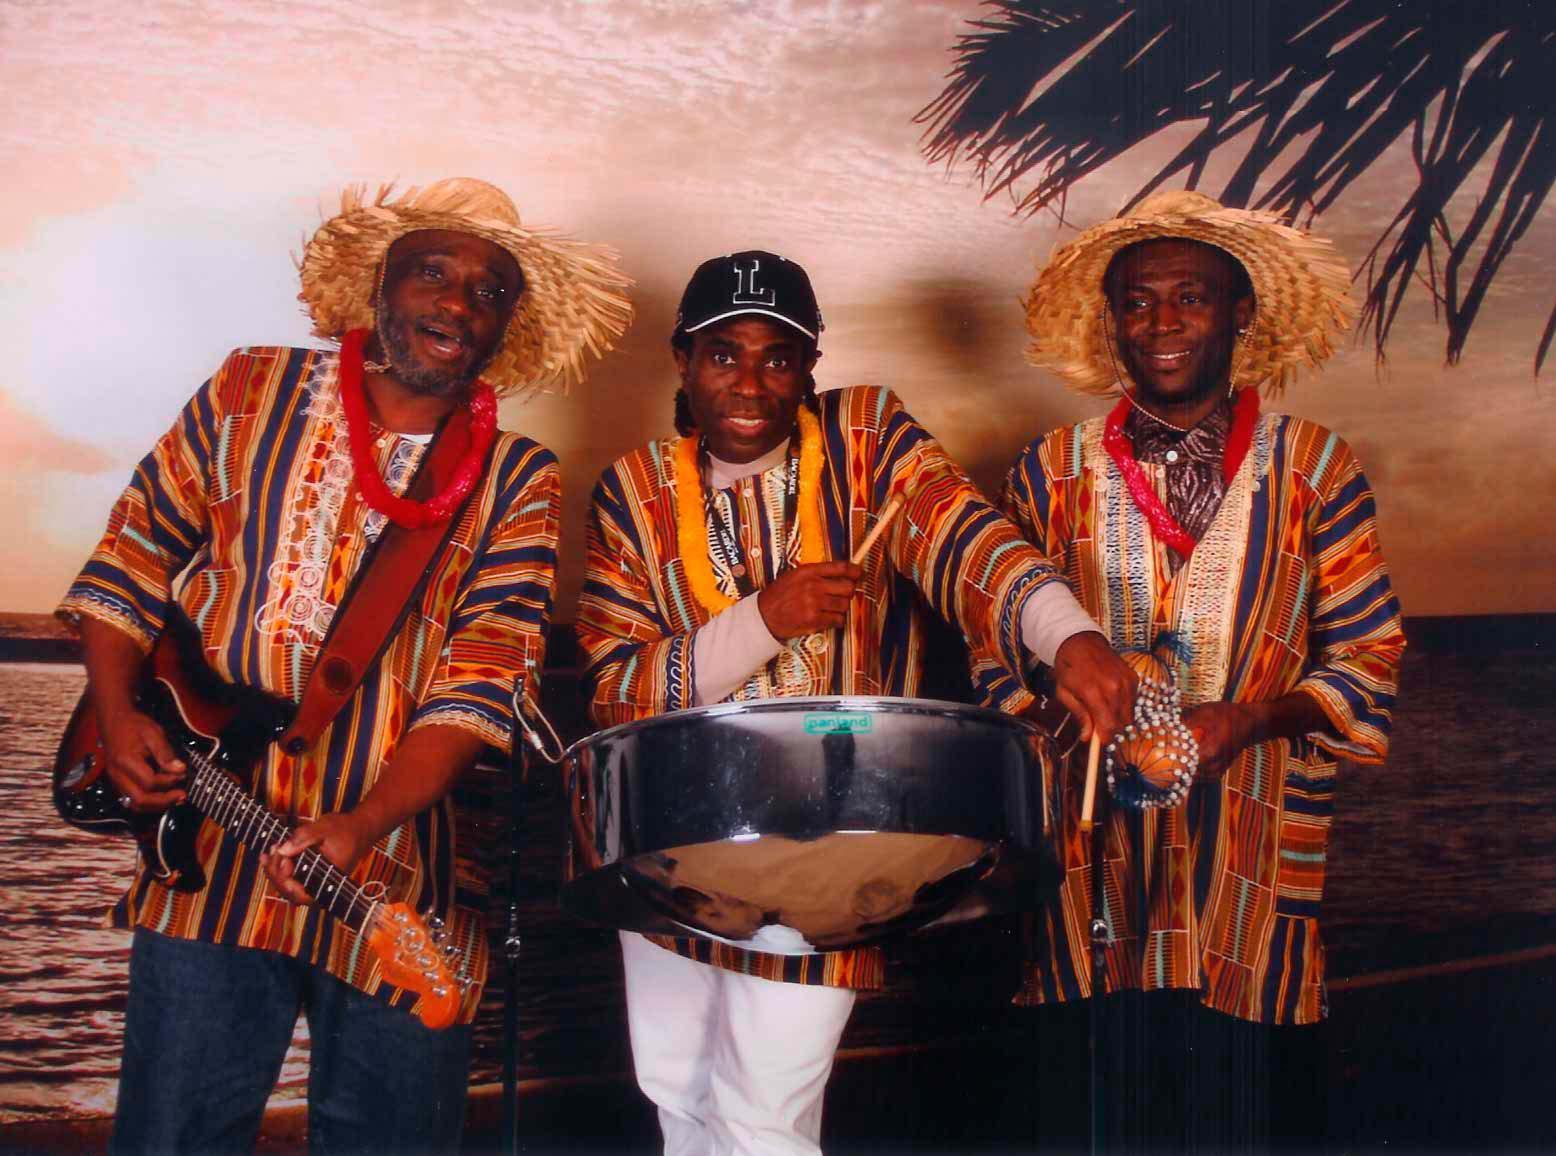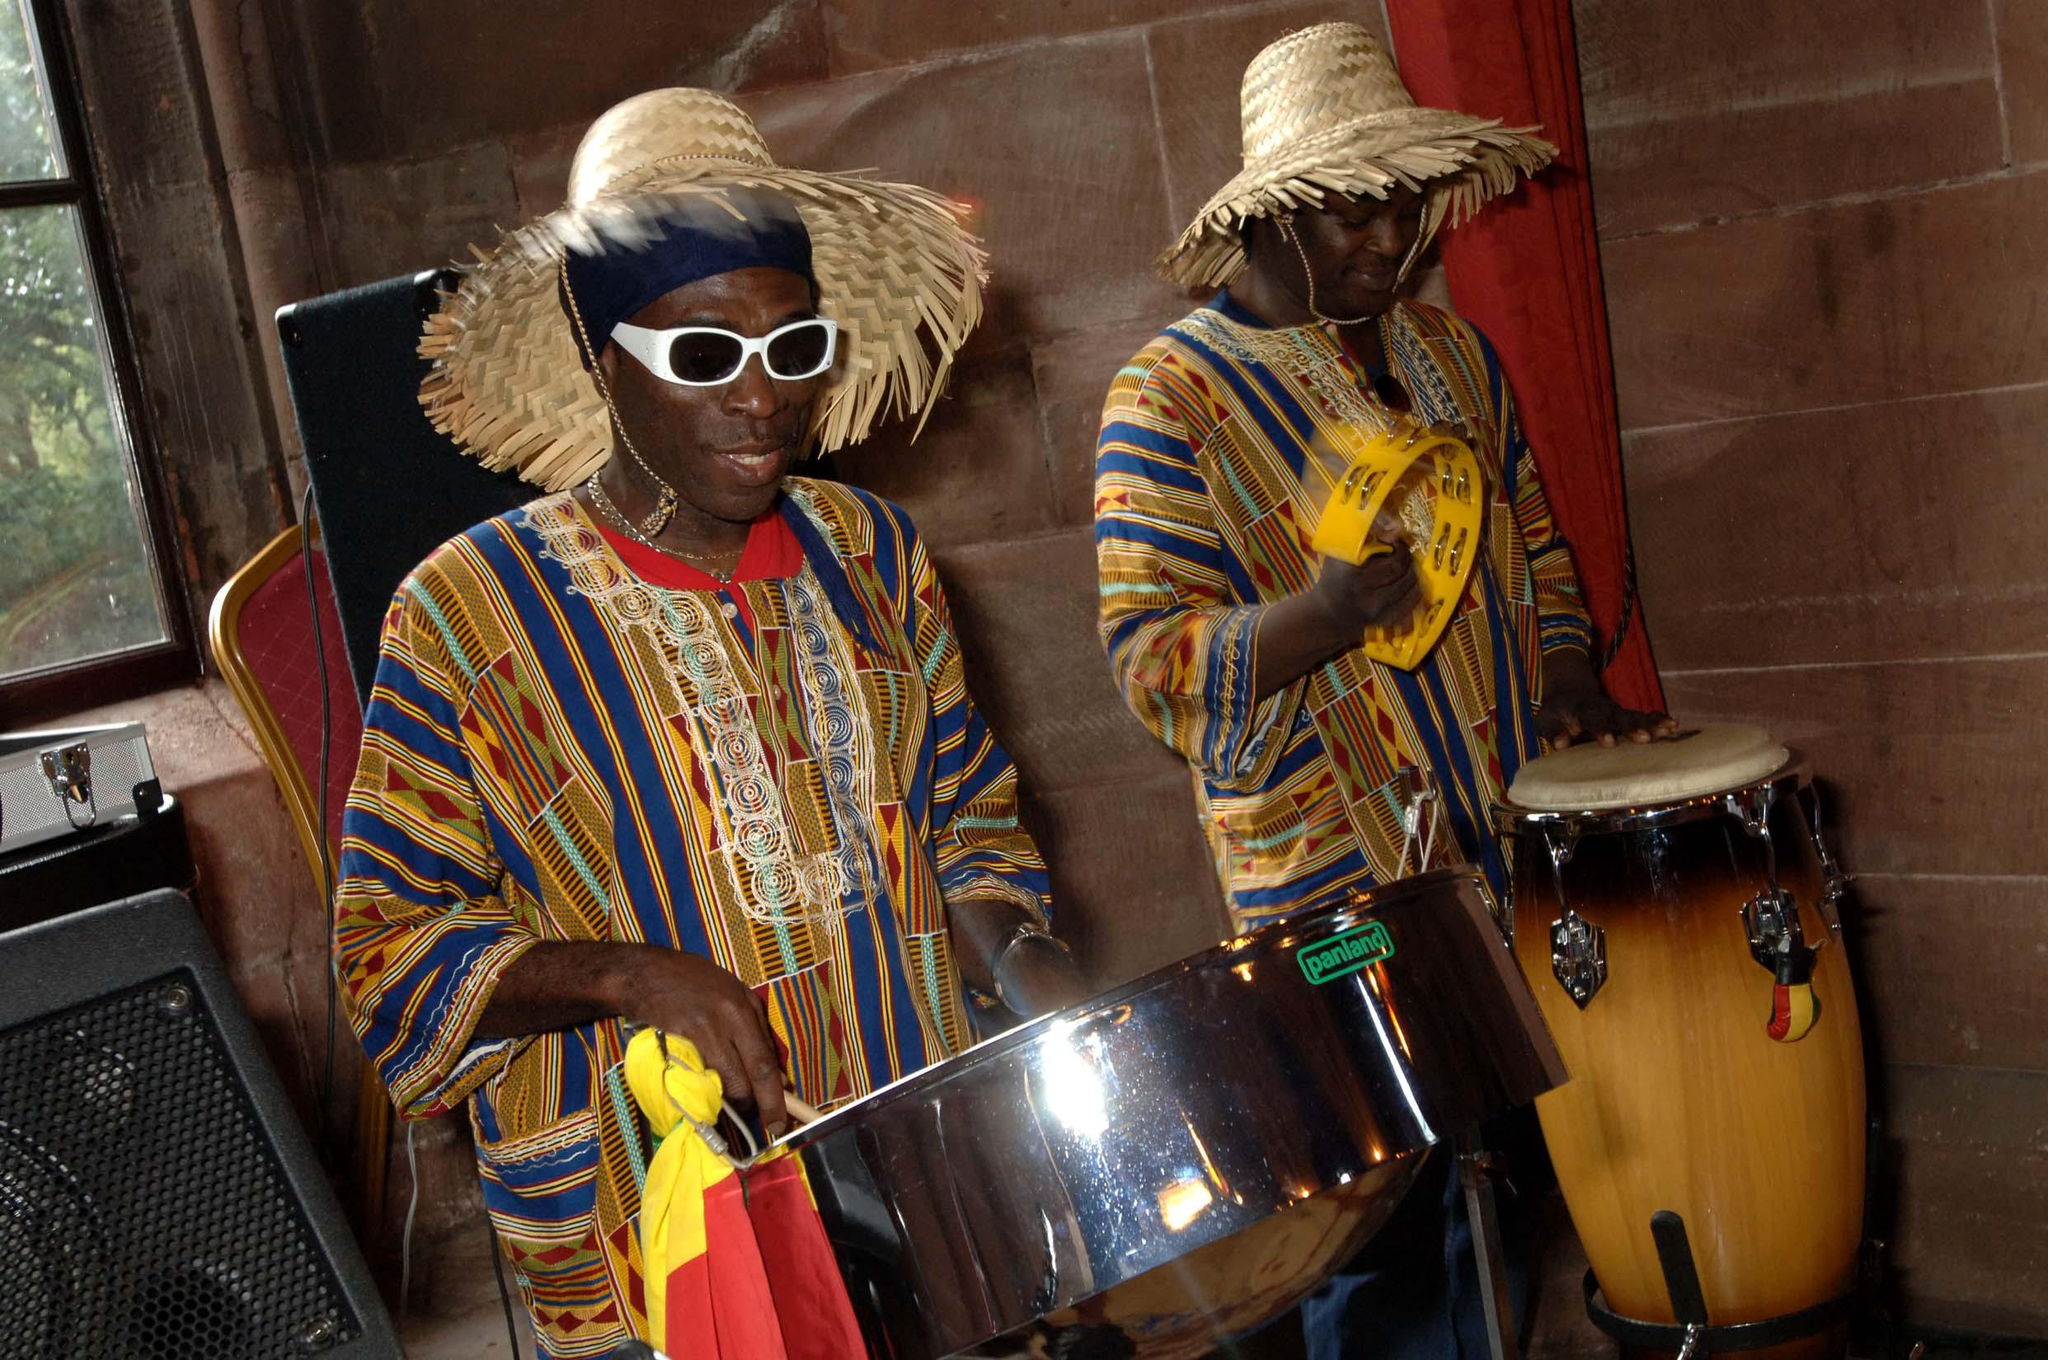The first image is the image on the left, the second image is the image on the right. Evaluate the accuracy of this statement regarding the images: "The left image contains a row of three musicians in matching shirts, and at least one of them holds drumsticks and has a steel drum at his front.". Is it true? Answer yes or no. Yes. The first image is the image on the left, the second image is the image on the right. Analyze the images presented: Is the assertion "Exactly one person is playing steel drums." valid? Answer yes or no. Yes. 